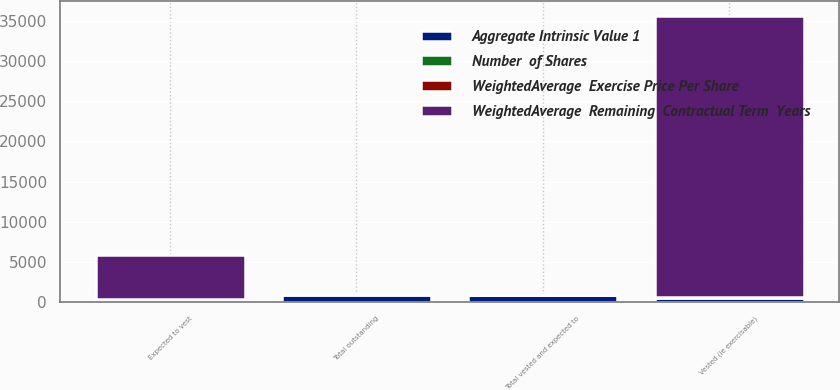Convert chart to OTSL. <chart><loc_0><loc_0><loc_500><loc_500><stacked_bar_chart><ecel><fcel>Vested (ie exercisable)<fcel>Expected to vest<fcel>Total vested and expected to<fcel>Total outstanding<nl><fcel>WeightedAverage  Remaining  Contractual Term  Years<fcel>35059<fcel>5490<fcel>33.28<fcel>33.28<nl><fcel>Number  of Shares<fcel>33.95<fcel>24.01<fcel>32.61<fcel>32.51<nl><fcel>WeightedAverage  Exercise Price Per Share<fcel>3.91<fcel>6.48<fcel>4.25<fcel>4.28<nl><fcel>Aggregate Intrinsic Value 1<fcel>549<fcel>325<fcel>874<fcel>925<nl></chart> 